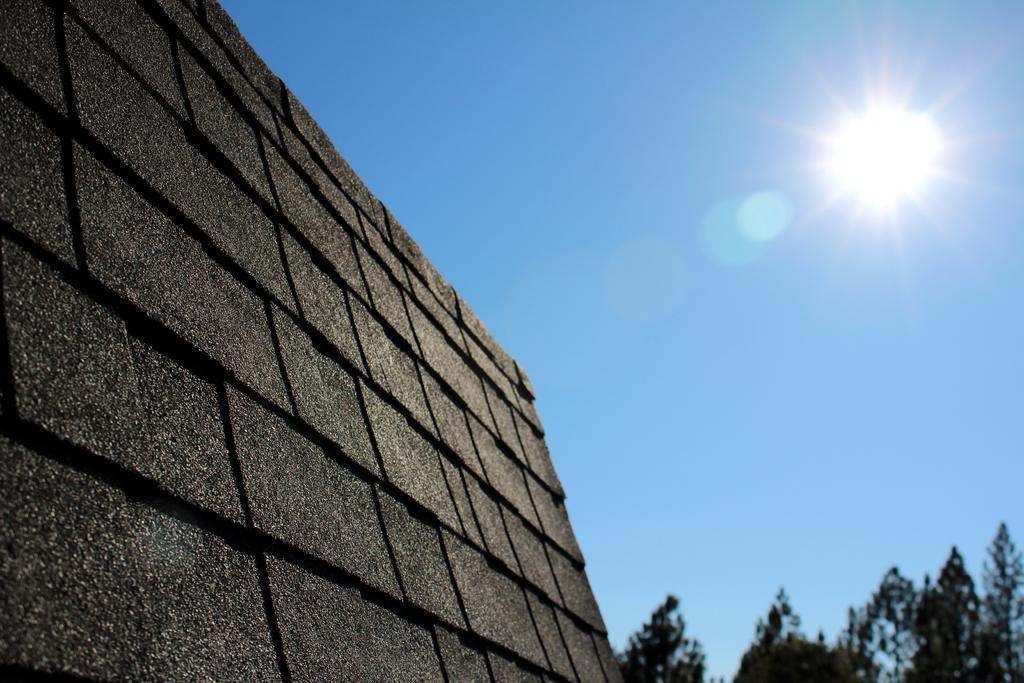How would you summarize this image in a sentence or two? In this image, there is a wall. At the bottom right side of the image, there are trees. In the background, I can see the sun in the sky. 